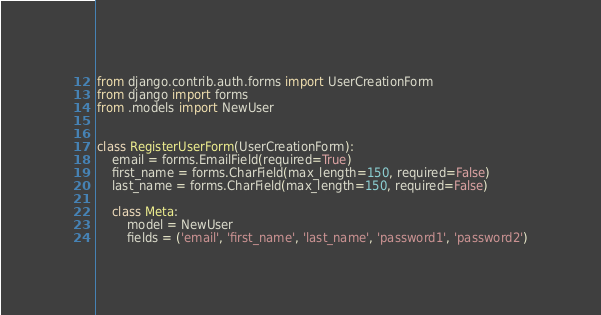<code> <loc_0><loc_0><loc_500><loc_500><_Python_>from django.contrib.auth.forms import UserCreationForm
from django import forms
from .models import NewUser


class RegisterUserForm(UserCreationForm):
    email = forms.EmailField(required=True)
    first_name = forms.CharField(max_length=150, required=False)
    last_name = forms.CharField(max_length=150, required=False)

    class Meta:
        model = NewUser
        fields = ('email', 'first_name', 'last_name', 'password1', 'password2')
</code> 